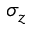<formula> <loc_0><loc_0><loc_500><loc_500>\sigma _ { z }</formula> 